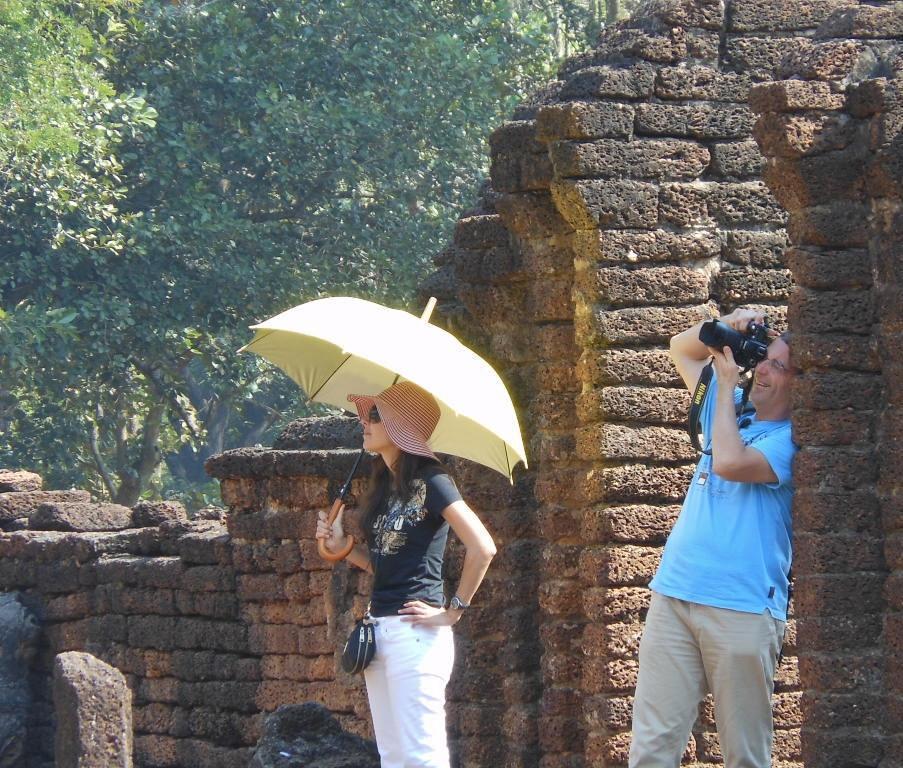How many umbrellas are there?
Give a very brief answer. 1. How many people are there?
Give a very brief answer. 2. 